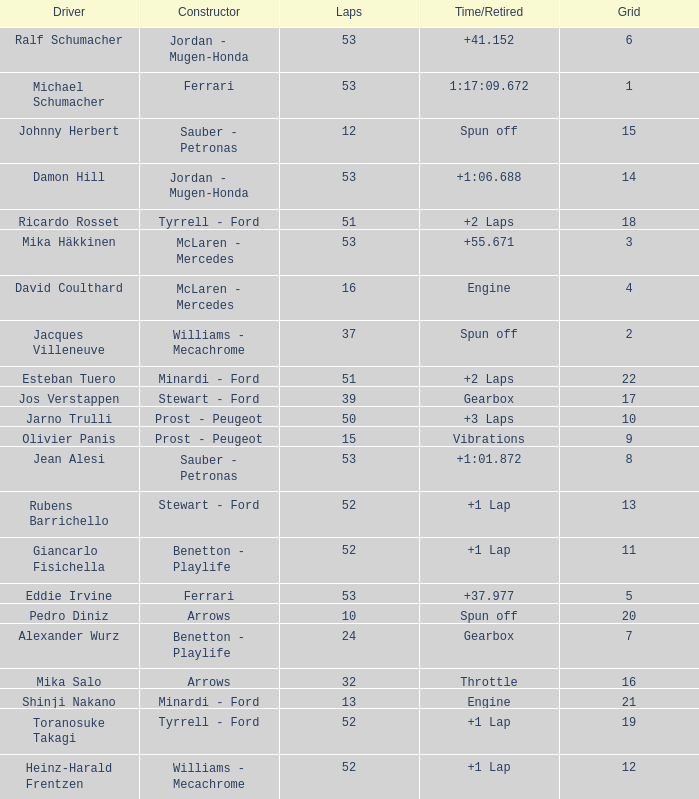What is the grid total for ralf schumacher racing over 53 laps? None. Could you parse the entire table as a dict? {'header': ['Driver', 'Constructor', 'Laps', 'Time/Retired', 'Grid'], 'rows': [['Ralf Schumacher', 'Jordan - Mugen-Honda', '53', '+41.152', '6'], ['Michael Schumacher', 'Ferrari', '53', '1:17:09.672', '1'], ['Johnny Herbert', 'Sauber - Petronas', '12', 'Spun off', '15'], ['Damon Hill', 'Jordan - Mugen-Honda', '53', '+1:06.688', '14'], ['Ricardo Rosset', 'Tyrrell - Ford', '51', '+2 Laps', '18'], ['Mika Häkkinen', 'McLaren - Mercedes', '53', '+55.671', '3'], ['David Coulthard', 'McLaren - Mercedes', '16', 'Engine', '4'], ['Jacques Villeneuve', 'Williams - Mecachrome', '37', 'Spun off', '2'], ['Esteban Tuero', 'Minardi - Ford', '51', '+2 Laps', '22'], ['Jos Verstappen', 'Stewart - Ford', '39', 'Gearbox', '17'], ['Jarno Trulli', 'Prost - Peugeot', '50', '+3 Laps', '10'], ['Olivier Panis', 'Prost - Peugeot', '15', 'Vibrations', '9'], ['Jean Alesi', 'Sauber - Petronas', '53', '+1:01.872', '8'], ['Rubens Barrichello', 'Stewart - Ford', '52', '+1 Lap', '13'], ['Giancarlo Fisichella', 'Benetton - Playlife', '52', '+1 Lap', '11'], ['Eddie Irvine', 'Ferrari', '53', '+37.977', '5'], ['Pedro Diniz', 'Arrows', '10', 'Spun off', '20'], ['Alexander Wurz', 'Benetton - Playlife', '24', 'Gearbox', '7'], ['Mika Salo', 'Arrows', '32', 'Throttle', '16'], ['Shinji Nakano', 'Minardi - Ford', '13', 'Engine', '21'], ['Toranosuke Takagi', 'Tyrrell - Ford', '52', '+1 Lap', '19'], ['Heinz-Harald Frentzen', 'Williams - Mecachrome', '52', '+1 Lap', '12']]} 